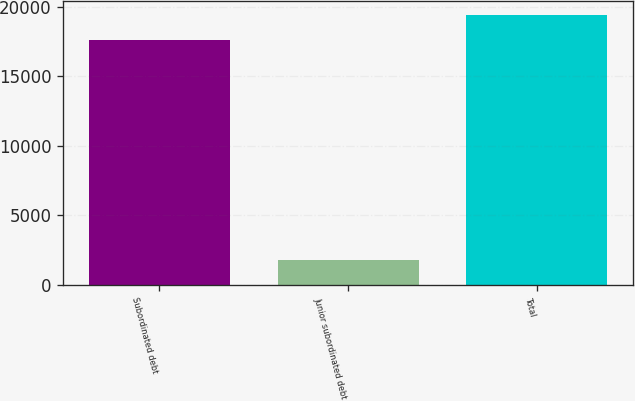Convert chart to OTSL. <chart><loc_0><loc_0><loc_500><loc_500><bar_chart><fcel>Subordinated debt<fcel>Junior subordinated debt<fcel>Total<nl><fcel>17604<fcel>1809<fcel>19413<nl></chart> 